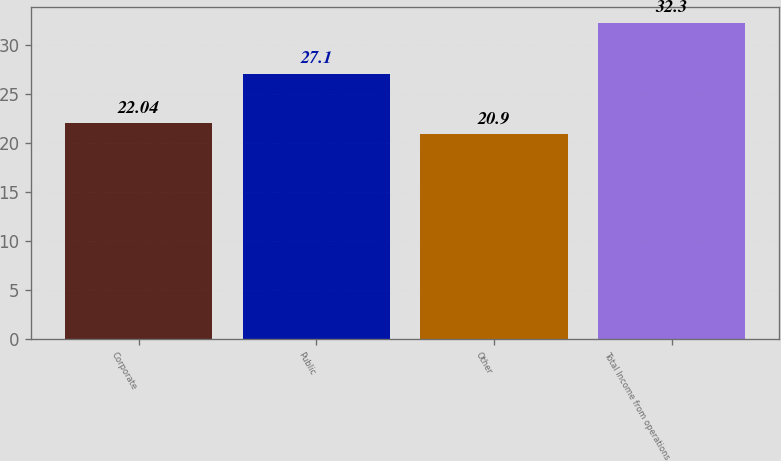Convert chart to OTSL. <chart><loc_0><loc_0><loc_500><loc_500><bar_chart><fcel>Corporate<fcel>Public<fcel>Other<fcel>Total Income from operations<nl><fcel>22.04<fcel>27.1<fcel>20.9<fcel>32.3<nl></chart> 